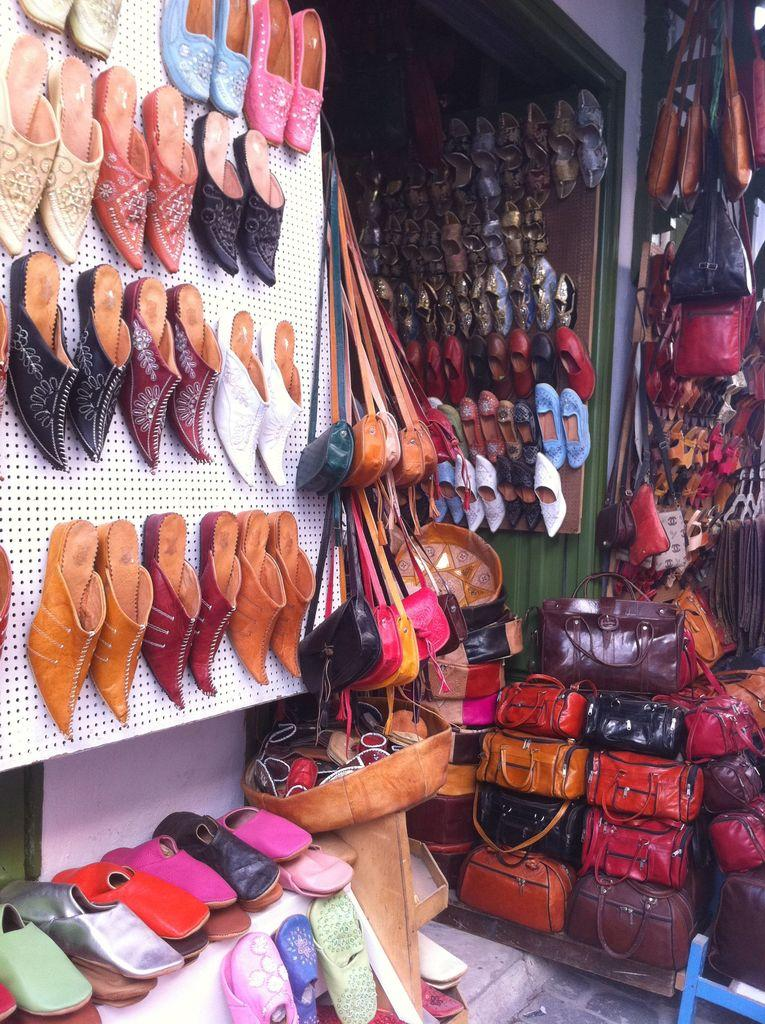What type of establishment is shown in the image? There is a shop in the image. What items can be found in the shop? The shop contains bags and footwear. What type of vacation is being advertised in the shop window? There is no vacation being advertised in the image, as it only shows a shop containing bags and footwear. How many coaches are visible in the shop? There are no coaches present in the image. 